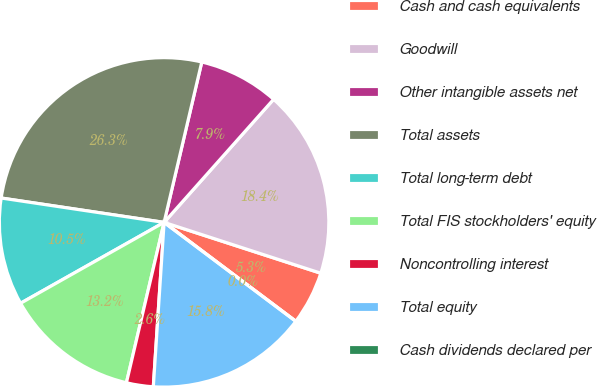Convert chart. <chart><loc_0><loc_0><loc_500><loc_500><pie_chart><fcel>Cash and cash equivalents<fcel>Goodwill<fcel>Other intangible assets net<fcel>Total assets<fcel>Total long-term debt<fcel>Total FIS stockholders' equity<fcel>Noncontrolling interest<fcel>Total equity<fcel>Cash dividends declared per<nl><fcel>5.26%<fcel>18.42%<fcel>7.9%<fcel>26.31%<fcel>10.53%<fcel>13.16%<fcel>2.63%<fcel>15.79%<fcel>0.0%<nl></chart> 